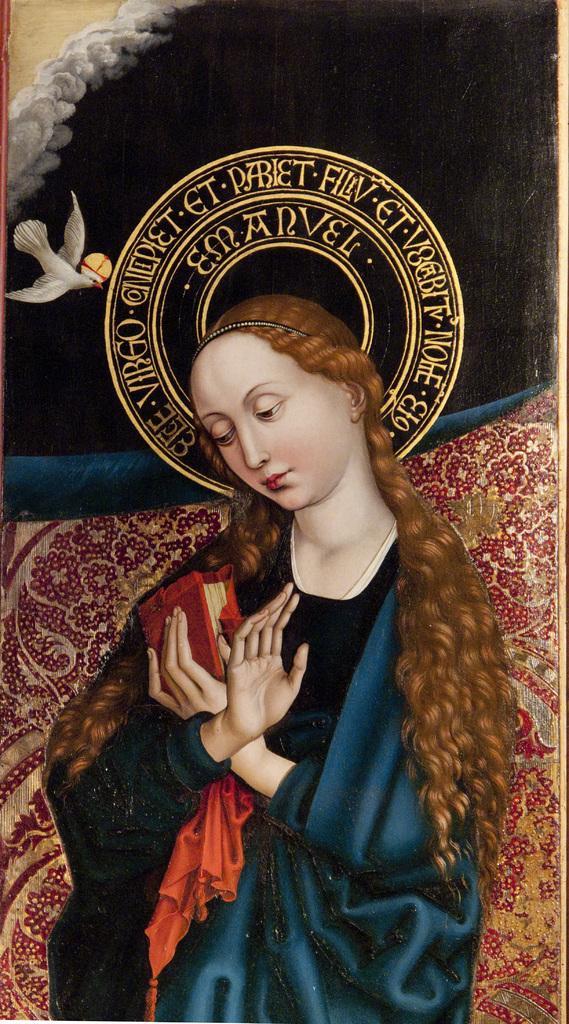Please provide a concise description of this image. This image is a painting. In this we can see a lady, book and a bird. 